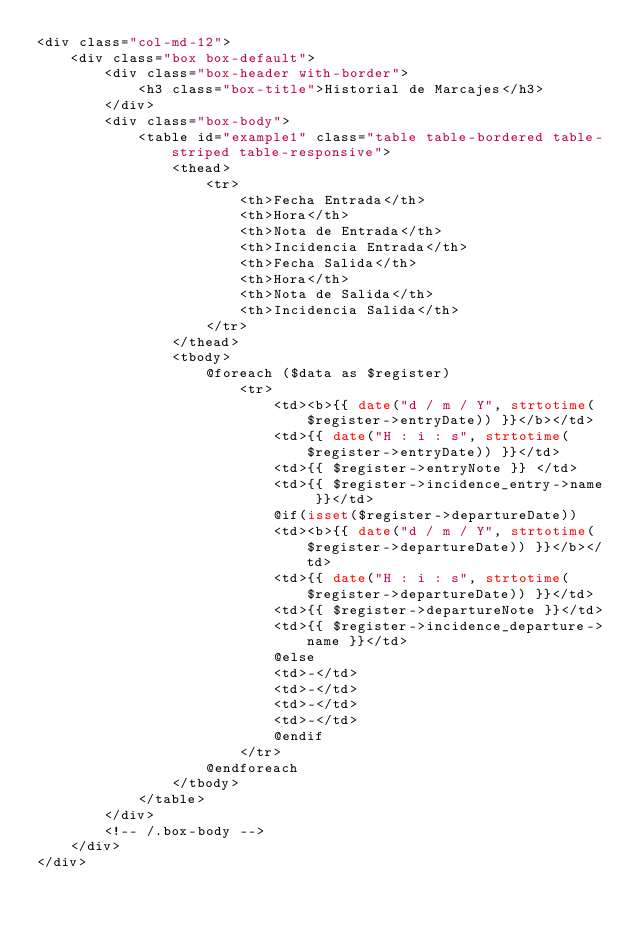<code> <loc_0><loc_0><loc_500><loc_500><_PHP_><div class="col-md-12">
    <div class="box box-default">
        <div class="box-header with-border">
            <h3 class="box-title">Historial de Marcajes</h3>
        </div>
        <div class="box-body">
            <table id="example1" class="table table-bordered table-striped table-responsive">
                <thead>
                    <tr>
                        <th>Fecha Entrada</th>
                        <th>Hora</th>
                        <th>Nota de Entrada</th>
                        <th>Incidencia Entrada</th>
                        <th>Fecha Salida</th>
                        <th>Hora</th>
                        <th>Nota de Salida</th>
                        <th>Incidencia Salida</th>
                    </tr>
                </thead>
                <tbody>
                    @foreach ($data as $register)
                        <tr>
                            <td><b>{{ date("d / m / Y", strtotime($register->entryDate)) }}</b></td>
                            <td>{{ date("H : i : s", strtotime($register->entryDate)) }}</td>
                            <td>{{ $register->entryNote }} </td>
                            <td>{{ $register->incidence_entry->name }}</td>
                            @if(isset($register->departureDate))
                            <td><b>{{ date("d / m / Y", strtotime($register->departureDate)) }}</b></td>
                            <td>{{ date("H : i : s", strtotime($register->departureDate)) }}</td>
                            <td>{{ $register->departureNote }}</td>
                            <td>{{ $register->incidence_departure->name }}</td>
                            @else
                            <td>-</td>
                            <td>-</td>
                            <td>-</td>
                            <td>-</td>
                            @endif
                        </tr>
                    @endforeach
                </tbody>
            </table>
        </div>
        <!-- /.box-body -->
    </div>
</div></code> 